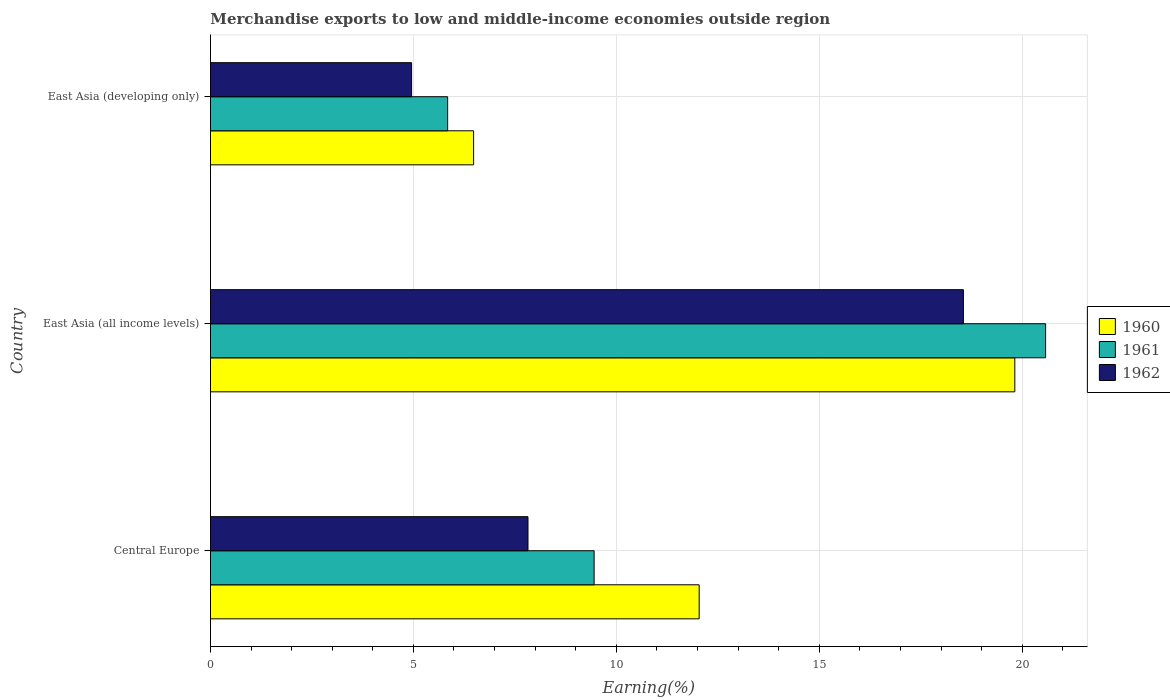How many different coloured bars are there?
Provide a succinct answer. 3. How many groups of bars are there?
Ensure brevity in your answer.  3. Are the number of bars per tick equal to the number of legend labels?
Ensure brevity in your answer.  Yes. How many bars are there on the 2nd tick from the top?
Offer a very short reply. 3. How many bars are there on the 2nd tick from the bottom?
Make the answer very short. 3. What is the label of the 3rd group of bars from the top?
Provide a succinct answer. Central Europe. In how many cases, is the number of bars for a given country not equal to the number of legend labels?
Your answer should be very brief. 0. What is the percentage of amount earned from merchandise exports in 1962 in Central Europe?
Your answer should be compact. 7.82. Across all countries, what is the maximum percentage of amount earned from merchandise exports in 1960?
Your response must be concise. 19.82. Across all countries, what is the minimum percentage of amount earned from merchandise exports in 1961?
Keep it short and to the point. 5.84. In which country was the percentage of amount earned from merchandise exports in 1961 maximum?
Ensure brevity in your answer.  East Asia (all income levels). In which country was the percentage of amount earned from merchandise exports in 1962 minimum?
Your answer should be very brief. East Asia (developing only). What is the total percentage of amount earned from merchandise exports in 1960 in the graph?
Make the answer very short. 38.34. What is the difference between the percentage of amount earned from merchandise exports in 1960 in Central Europe and that in East Asia (all income levels)?
Provide a short and direct response. -7.78. What is the difference between the percentage of amount earned from merchandise exports in 1961 in East Asia (all income levels) and the percentage of amount earned from merchandise exports in 1960 in Central Europe?
Keep it short and to the point. 8.54. What is the average percentage of amount earned from merchandise exports in 1961 per country?
Your answer should be very brief. 11.96. What is the difference between the percentage of amount earned from merchandise exports in 1961 and percentage of amount earned from merchandise exports in 1962 in Central Europe?
Your response must be concise. 1.63. What is the ratio of the percentage of amount earned from merchandise exports in 1962 in Central Europe to that in East Asia (developing only)?
Provide a short and direct response. 1.58. Is the difference between the percentage of amount earned from merchandise exports in 1961 in East Asia (all income levels) and East Asia (developing only) greater than the difference between the percentage of amount earned from merchandise exports in 1962 in East Asia (all income levels) and East Asia (developing only)?
Give a very brief answer. Yes. What is the difference between the highest and the second highest percentage of amount earned from merchandise exports in 1960?
Ensure brevity in your answer.  7.78. What is the difference between the highest and the lowest percentage of amount earned from merchandise exports in 1960?
Offer a terse response. 13.33. In how many countries, is the percentage of amount earned from merchandise exports in 1960 greater than the average percentage of amount earned from merchandise exports in 1960 taken over all countries?
Ensure brevity in your answer.  1. What does the 1st bar from the top in East Asia (all income levels) represents?
Make the answer very short. 1962. Does the graph contain any zero values?
Your response must be concise. No. How many legend labels are there?
Provide a succinct answer. 3. What is the title of the graph?
Offer a terse response. Merchandise exports to low and middle-income economies outside region. Does "2007" appear as one of the legend labels in the graph?
Your response must be concise. No. What is the label or title of the X-axis?
Your answer should be compact. Earning(%). What is the label or title of the Y-axis?
Your answer should be very brief. Country. What is the Earning(%) in 1960 in Central Europe?
Offer a very short reply. 12.04. What is the Earning(%) of 1961 in Central Europe?
Make the answer very short. 9.45. What is the Earning(%) in 1962 in Central Europe?
Your answer should be very brief. 7.82. What is the Earning(%) of 1960 in East Asia (all income levels)?
Provide a short and direct response. 19.82. What is the Earning(%) in 1961 in East Asia (all income levels)?
Keep it short and to the point. 20.58. What is the Earning(%) of 1962 in East Asia (all income levels)?
Ensure brevity in your answer.  18.55. What is the Earning(%) in 1960 in East Asia (developing only)?
Your answer should be compact. 6.48. What is the Earning(%) of 1961 in East Asia (developing only)?
Provide a succinct answer. 5.84. What is the Earning(%) in 1962 in East Asia (developing only)?
Give a very brief answer. 4.96. Across all countries, what is the maximum Earning(%) of 1960?
Provide a succinct answer. 19.82. Across all countries, what is the maximum Earning(%) of 1961?
Your answer should be compact. 20.58. Across all countries, what is the maximum Earning(%) in 1962?
Offer a very short reply. 18.55. Across all countries, what is the minimum Earning(%) in 1960?
Give a very brief answer. 6.48. Across all countries, what is the minimum Earning(%) in 1961?
Give a very brief answer. 5.84. Across all countries, what is the minimum Earning(%) in 1962?
Provide a short and direct response. 4.96. What is the total Earning(%) in 1960 in the graph?
Provide a short and direct response. 38.34. What is the total Earning(%) of 1961 in the graph?
Keep it short and to the point. 35.87. What is the total Earning(%) of 1962 in the graph?
Ensure brevity in your answer.  31.33. What is the difference between the Earning(%) in 1960 in Central Europe and that in East Asia (all income levels)?
Provide a short and direct response. -7.78. What is the difference between the Earning(%) of 1961 in Central Europe and that in East Asia (all income levels)?
Your response must be concise. -11.12. What is the difference between the Earning(%) in 1962 in Central Europe and that in East Asia (all income levels)?
Your answer should be very brief. -10.73. What is the difference between the Earning(%) in 1960 in Central Europe and that in East Asia (developing only)?
Your response must be concise. 5.56. What is the difference between the Earning(%) in 1961 in Central Europe and that in East Asia (developing only)?
Keep it short and to the point. 3.61. What is the difference between the Earning(%) in 1962 in Central Europe and that in East Asia (developing only)?
Provide a succinct answer. 2.87. What is the difference between the Earning(%) in 1960 in East Asia (all income levels) and that in East Asia (developing only)?
Keep it short and to the point. 13.33. What is the difference between the Earning(%) in 1961 in East Asia (all income levels) and that in East Asia (developing only)?
Provide a short and direct response. 14.73. What is the difference between the Earning(%) of 1962 in East Asia (all income levels) and that in East Asia (developing only)?
Offer a terse response. 13.6. What is the difference between the Earning(%) in 1960 in Central Europe and the Earning(%) in 1961 in East Asia (all income levels)?
Provide a succinct answer. -8.54. What is the difference between the Earning(%) of 1960 in Central Europe and the Earning(%) of 1962 in East Asia (all income levels)?
Ensure brevity in your answer.  -6.51. What is the difference between the Earning(%) in 1961 in Central Europe and the Earning(%) in 1962 in East Asia (all income levels)?
Your response must be concise. -9.1. What is the difference between the Earning(%) in 1960 in Central Europe and the Earning(%) in 1961 in East Asia (developing only)?
Offer a terse response. 6.2. What is the difference between the Earning(%) of 1960 in Central Europe and the Earning(%) of 1962 in East Asia (developing only)?
Your answer should be very brief. 7.09. What is the difference between the Earning(%) of 1961 in Central Europe and the Earning(%) of 1962 in East Asia (developing only)?
Keep it short and to the point. 4.5. What is the difference between the Earning(%) of 1960 in East Asia (all income levels) and the Earning(%) of 1961 in East Asia (developing only)?
Your response must be concise. 13.97. What is the difference between the Earning(%) of 1960 in East Asia (all income levels) and the Earning(%) of 1962 in East Asia (developing only)?
Make the answer very short. 14.86. What is the difference between the Earning(%) in 1961 in East Asia (all income levels) and the Earning(%) in 1962 in East Asia (developing only)?
Your response must be concise. 15.62. What is the average Earning(%) of 1960 per country?
Your response must be concise. 12.78. What is the average Earning(%) of 1961 per country?
Make the answer very short. 11.96. What is the average Earning(%) of 1962 per country?
Ensure brevity in your answer.  10.44. What is the difference between the Earning(%) in 1960 and Earning(%) in 1961 in Central Europe?
Make the answer very short. 2.59. What is the difference between the Earning(%) in 1960 and Earning(%) in 1962 in Central Europe?
Your answer should be very brief. 4.22. What is the difference between the Earning(%) of 1961 and Earning(%) of 1962 in Central Europe?
Ensure brevity in your answer.  1.63. What is the difference between the Earning(%) in 1960 and Earning(%) in 1961 in East Asia (all income levels)?
Provide a succinct answer. -0.76. What is the difference between the Earning(%) of 1960 and Earning(%) of 1962 in East Asia (all income levels)?
Provide a short and direct response. 1.27. What is the difference between the Earning(%) in 1961 and Earning(%) in 1962 in East Asia (all income levels)?
Your answer should be very brief. 2.03. What is the difference between the Earning(%) of 1960 and Earning(%) of 1961 in East Asia (developing only)?
Offer a terse response. 0.64. What is the difference between the Earning(%) in 1960 and Earning(%) in 1962 in East Asia (developing only)?
Offer a terse response. 1.53. What is the difference between the Earning(%) in 1961 and Earning(%) in 1962 in East Asia (developing only)?
Give a very brief answer. 0.89. What is the ratio of the Earning(%) in 1960 in Central Europe to that in East Asia (all income levels)?
Give a very brief answer. 0.61. What is the ratio of the Earning(%) in 1961 in Central Europe to that in East Asia (all income levels)?
Provide a short and direct response. 0.46. What is the ratio of the Earning(%) of 1962 in Central Europe to that in East Asia (all income levels)?
Your answer should be very brief. 0.42. What is the ratio of the Earning(%) of 1960 in Central Europe to that in East Asia (developing only)?
Keep it short and to the point. 1.86. What is the ratio of the Earning(%) of 1961 in Central Europe to that in East Asia (developing only)?
Your answer should be compact. 1.62. What is the ratio of the Earning(%) of 1962 in Central Europe to that in East Asia (developing only)?
Keep it short and to the point. 1.58. What is the ratio of the Earning(%) in 1960 in East Asia (all income levels) to that in East Asia (developing only)?
Your answer should be compact. 3.06. What is the ratio of the Earning(%) in 1961 in East Asia (all income levels) to that in East Asia (developing only)?
Provide a succinct answer. 3.52. What is the ratio of the Earning(%) of 1962 in East Asia (all income levels) to that in East Asia (developing only)?
Offer a very short reply. 3.74. What is the difference between the highest and the second highest Earning(%) of 1960?
Your response must be concise. 7.78. What is the difference between the highest and the second highest Earning(%) of 1961?
Your answer should be compact. 11.12. What is the difference between the highest and the second highest Earning(%) of 1962?
Make the answer very short. 10.73. What is the difference between the highest and the lowest Earning(%) of 1960?
Provide a short and direct response. 13.33. What is the difference between the highest and the lowest Earning(%) of 1961?
Offer a very short reply. 14.73. What is the difference between the highest and the lowest Earning(%) in 1962?
Your response must be concise. 13.6. 